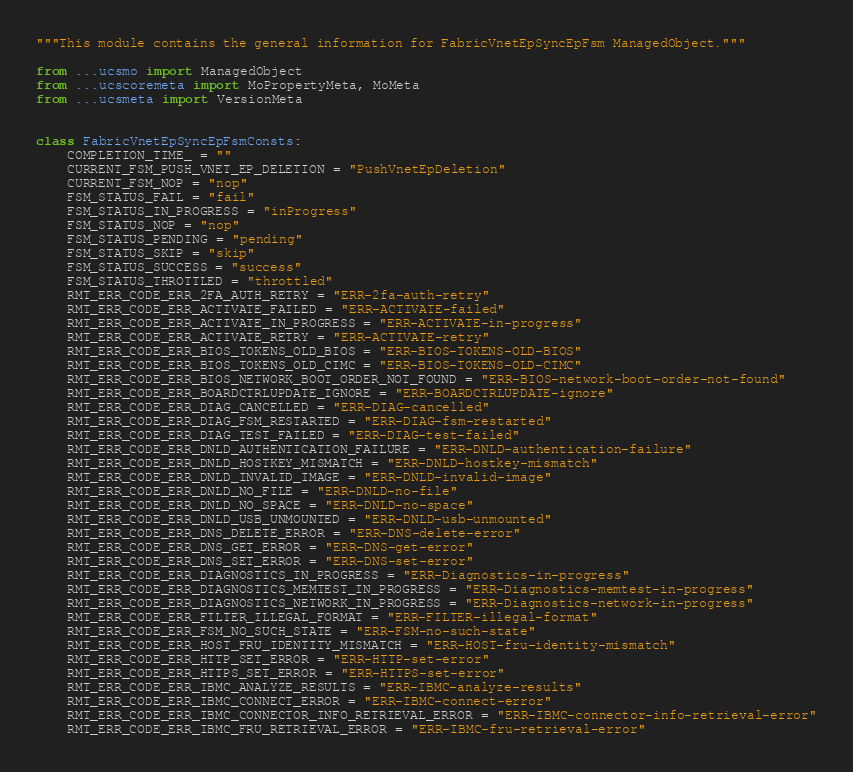Convert code to text. <code><loc_0><loc_0><loc_500><loc_500><_Python_>"""This module contains the general information for FabricVnetEpSyncEpFsm ManagedObject."""

from ...ucsmo import ManagedObject
from ...ucscoremeta import MoPropertyMeta, MoMeta
from ...ucsmeta import VersionMeta


class FabricVnetEpSyncEpFsmConsts:
    COMPLETION_TIME_ = ""
    CURRENT_FSM_PUSH_VNET_EP_DELETION = "PushVnetEpDeletion"
    CURRENT_FSM_NOP = "nop"
    FSM_STATUS_FAIL = "fail"
    FSM_STATUS_IN_PROGRESS = "inProgress"
    FSM_STATUS_NOP = "nop"
    FSM_STATUS_PENDING = "pending"
    FSM_STATUS_SKIP = "skip"
    FSM_STATUS_SUCCESS = "success"
    FSM_STATUS_THROTTLED = "throttled"
    RMT_ERR_CODE_ERR_2FA_AUTH_RETRY = "ERR-2fa-auth-retry"
    RMT_ERR_CODE_ERR_ACTIVATE_FAILED = "ERR-ACTIVATE-failed"
    RMT_ERR_CODE_ERR_ACTIVATE_IN_PROGRESS = "ERR-ACTIVATE-in-progress"
    RMT_ERR_CODE_ERR_ACTIVATE_RETRY = "ERR-ACTIVATE-retry"
    RMT_ERR_CODE_ERR_BIOS_TOKENS_OLD_BIOS = "ERR-BIOS-TOKENS-OLD-BIOS"
    RMT_ERR_CODE_ERR_BIOS_TOKENS_OLD_CIMC = "ERR-BIOS-TOKENS-OLD-CIMC"
    RMT_ERR_CODE_ERR_BIOS_NETWORK_BOOT_ORDER_NOT_FOUND = "ERR-BIOS-network-boot-order-not-found"
    RMT_ERR_CODE_ERR_BOARDCTRLUPDATE_IGNORE = "ERR-BOARDCTRLUPDATE-ignore"
    RMT_ERR_CODE_ERR_DIAG_CANCELLED = "ERR-DIAG-cancelled"
    RMT_ERR_CODE_ERR_DIAG_FSM_RESTARTED = "ERR-DIAG-fsm-restarted"
    RMT_ERR_CODE_ERR_DIAG_TEST_FAILED = "ERR-DIAG-test-failed"
    RMT_ERR_CODE_ERR_DNLD_AUTHENTICATION_FAILURE = "ERR-DNLD-authentication-failure"
    RMT_ERR_CODE_ERR_DNLD_HOSTKEY_MISMATCH = "ERR-DNLD-hostkey-mismatch"
    RMT_ERR_CODE_ERR_DNLD_INVALID_IMAGE = "ERR-DNLD-invalid-image"
    RMT_ERR_CODE_ERR_DNLD_NO_FILE = "ERR-DNLD-no-file"
    RMT_ERR_CODE_ERR_DNLD_NO_SPACE = "ERR-DNLD-no-space"
    RMT_ERR_CODE_ERR_DNLD_USB_UNMOUNTED = "ERR-DNLD-usb-unmounted"
    RMT_ERR_CODE_ERR_DNS_DELETE_ERROR = "ERR-DNS-delete-error"
    RMT_ERR_CODE_ERR_DNS_GET_ERROR = "ERR-DNS-get-error"
    RMT_ERR_CODE_ERR_DNS_SET_ERROR = "ERR-DNS-set-error"
    RMT_ERR_CODE_ERR_DIAGNOSTICS_IN_PROGRESS = "ERR-Diagnostics-in-progress"
    RMT_ERR_CODE_ERR_DIAGNOSTICS_MEMTEST_IN_PROGRESS = "ERR-Diagnostics-memtest-in-progress"
    RMT_ERR_CODE_ERR_DIAGNOSTICS_NETWORK_IN_PROGRESS = "ERR-Diagnostics-network-in-progress"
    RMT_ERR_CODE_ERR_FILTER_ILLEGAL_FORMAT = "ERR-FILTER-illegal-format"
    RMT_ERR_CODE_ERR_FSM_NO_SUCH_STATE = "ERR-FSM-no-such-state"
    RMT_ERR_CODE_ERR_HOST_FRU_IDENTITY_MISMATCH = "ERR-HOST-fru-identity-mismatch"
    RMT_ERR_CODE_ERR_HTTP_SET_ERROR = "ERR-HTTP-set-error"
    RMT_ERR_CODE_ERR_HTTPS_SET_ERROR = "ERR-HTTPS-set-error"
    RMT_ERR_CODE_ERR_IBMC_ANALYZE_RESULTS = "ERR-IBMC-analyze-results"
    RMT_ERR_CODE_ERR_IBMC_CONNECT_ERROR = "ERR-IBMC-connect-error"
    RMT_ERR_CODE_ERR_IBMC_CONNECTOR_INFO_RETRIEVAL_ERROR = "ERR-IBMC-connector-info-retrieval-error"
    RMT_ERR_CODE_ERR_IBMC_FRU_RETRIEVAL_ERROR = "ERR-IBMC-fru-retrieval-error"</code> 